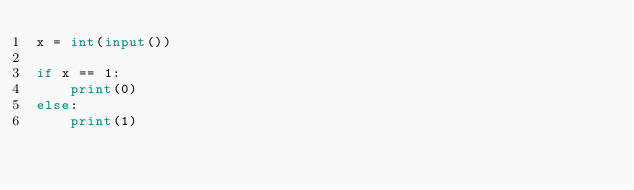<code> <loc_0><loc_0><loc_500><loc_500><_Python_>x = int(input())

if x == 1:
    print(0)
else:
    print(1)</code> 